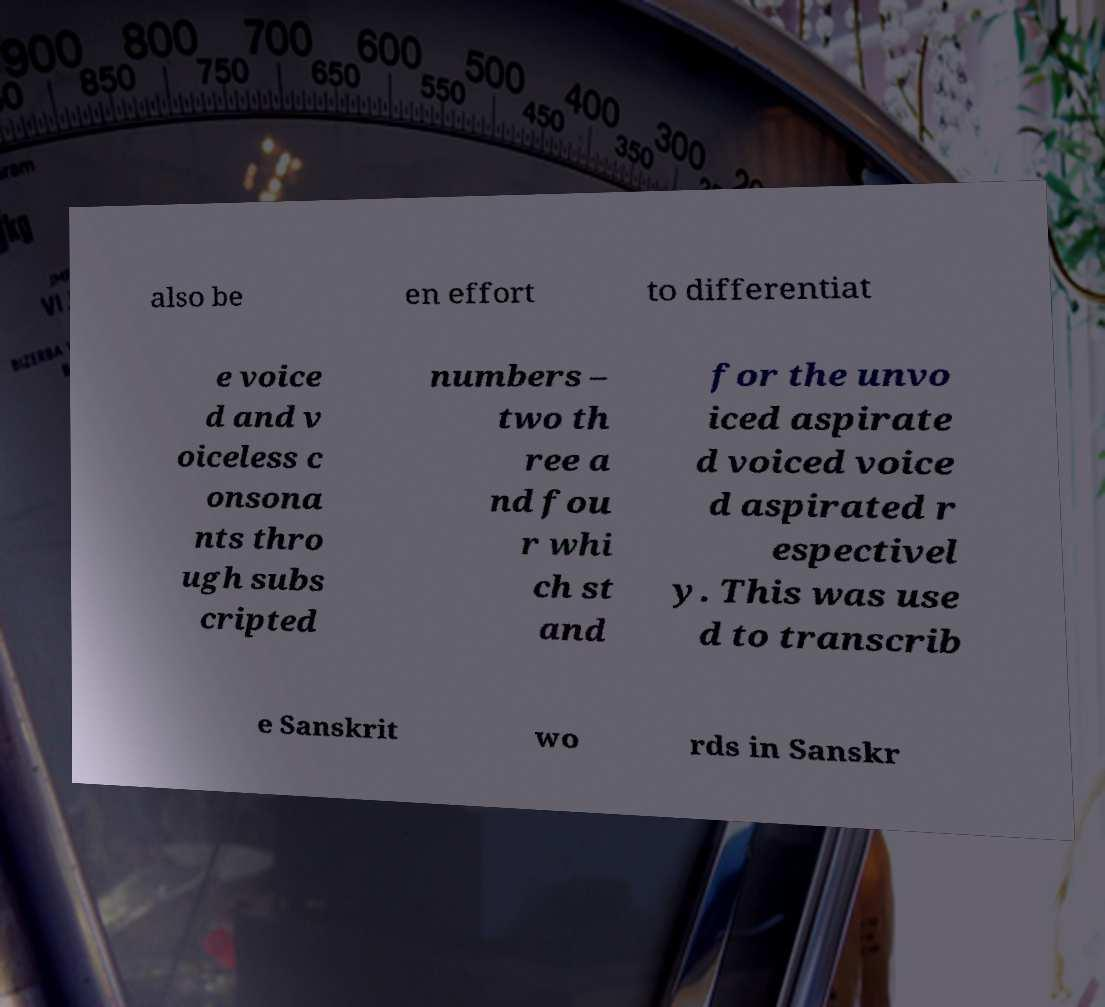For documentation purposes, I need the text within this image transcribed. Could you provide that? also be en effort to differentiat e voice d and v oiceless c onsona nts thro ugh subs cripted numbers – two th ree a nd fou r whi ch st and for the unvo iced aspirate d voiced voice d aspirated r espectivel y. This was use d to transcrib e Sanskrit wo rds in Sanskr 